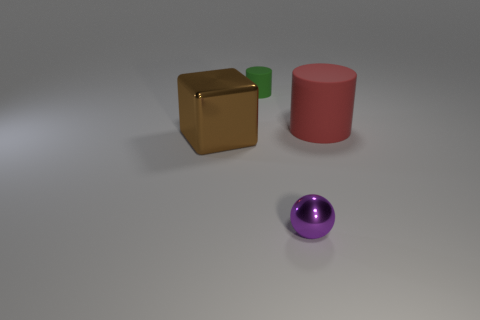Add 1 small blue balls. How many objects exist? 5 Subtract 0 brown spheres. How many objects are left? 4 Subtract all balls. How many objects are left? 3 Subtract 2 cylinders. How many cylinders are left? 0 Subtract all gray cylinders. Subtract all yellow blocks. How many cylinders are left? 2 Subtract all brown blocks. How many red cylinders are left? 1 Subtract all brown metallic things. Subtract all tiny metal objects. How many objects are left? 2 Add 3 tiny green rubber cylinders. How many tiny green rubber cylinders are left? 4 Add 3 tiny cyan rubber things. How many tiny cyan rubber things exist? 3 